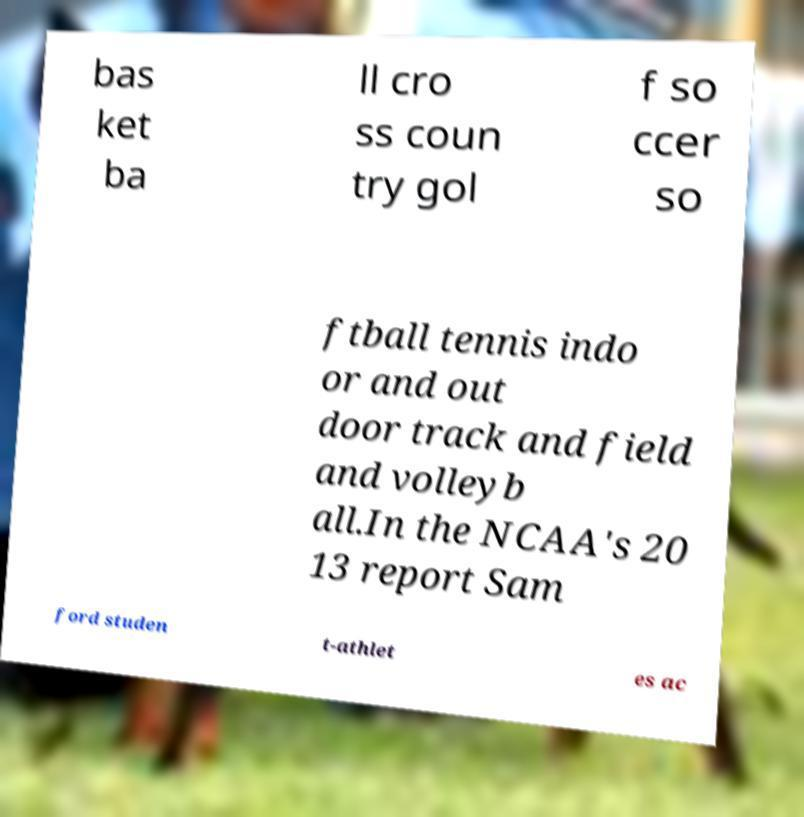For documentation purposes, I need the text within this image transcribed. Could you provide that? bas ket ba ll cro ss coun try gol f so ccer so ftball tennis indo or and out door track and field and volleyb all.In the NCAA's 20 13 report Sam ford studen t-athlet es ac 